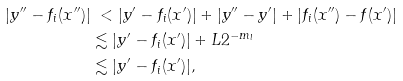Convert formula to latex. <formula><loc_0><loc_0><loc_500><loc_500>| y ^ { \prime \prime } - f _ { i } ( x ^ { \prime \prime } ) | & \ < | y ^ { \prime } - f _ { i } ( x ^ { \prime } ) | + | y ^ { \prime \prime } - y ^ { \prime } | + | f _ { i } ( x ^ { \prime \prime } ) - f ( x ^ { \prime } ) | \\ & \lesssim | y ^ { \prime } - f _ { i } ( x ^ { \prime } ) | + L 2 ^ { - m _ { l } } \\ & \lesssim | y ^ { \prime } - f _ { i } ( x ^ { \prime } ) | ,</formula> 